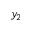<formula> <loc_0><loc_0><loc_500><loc_500>y _ { 2 }</formula> 